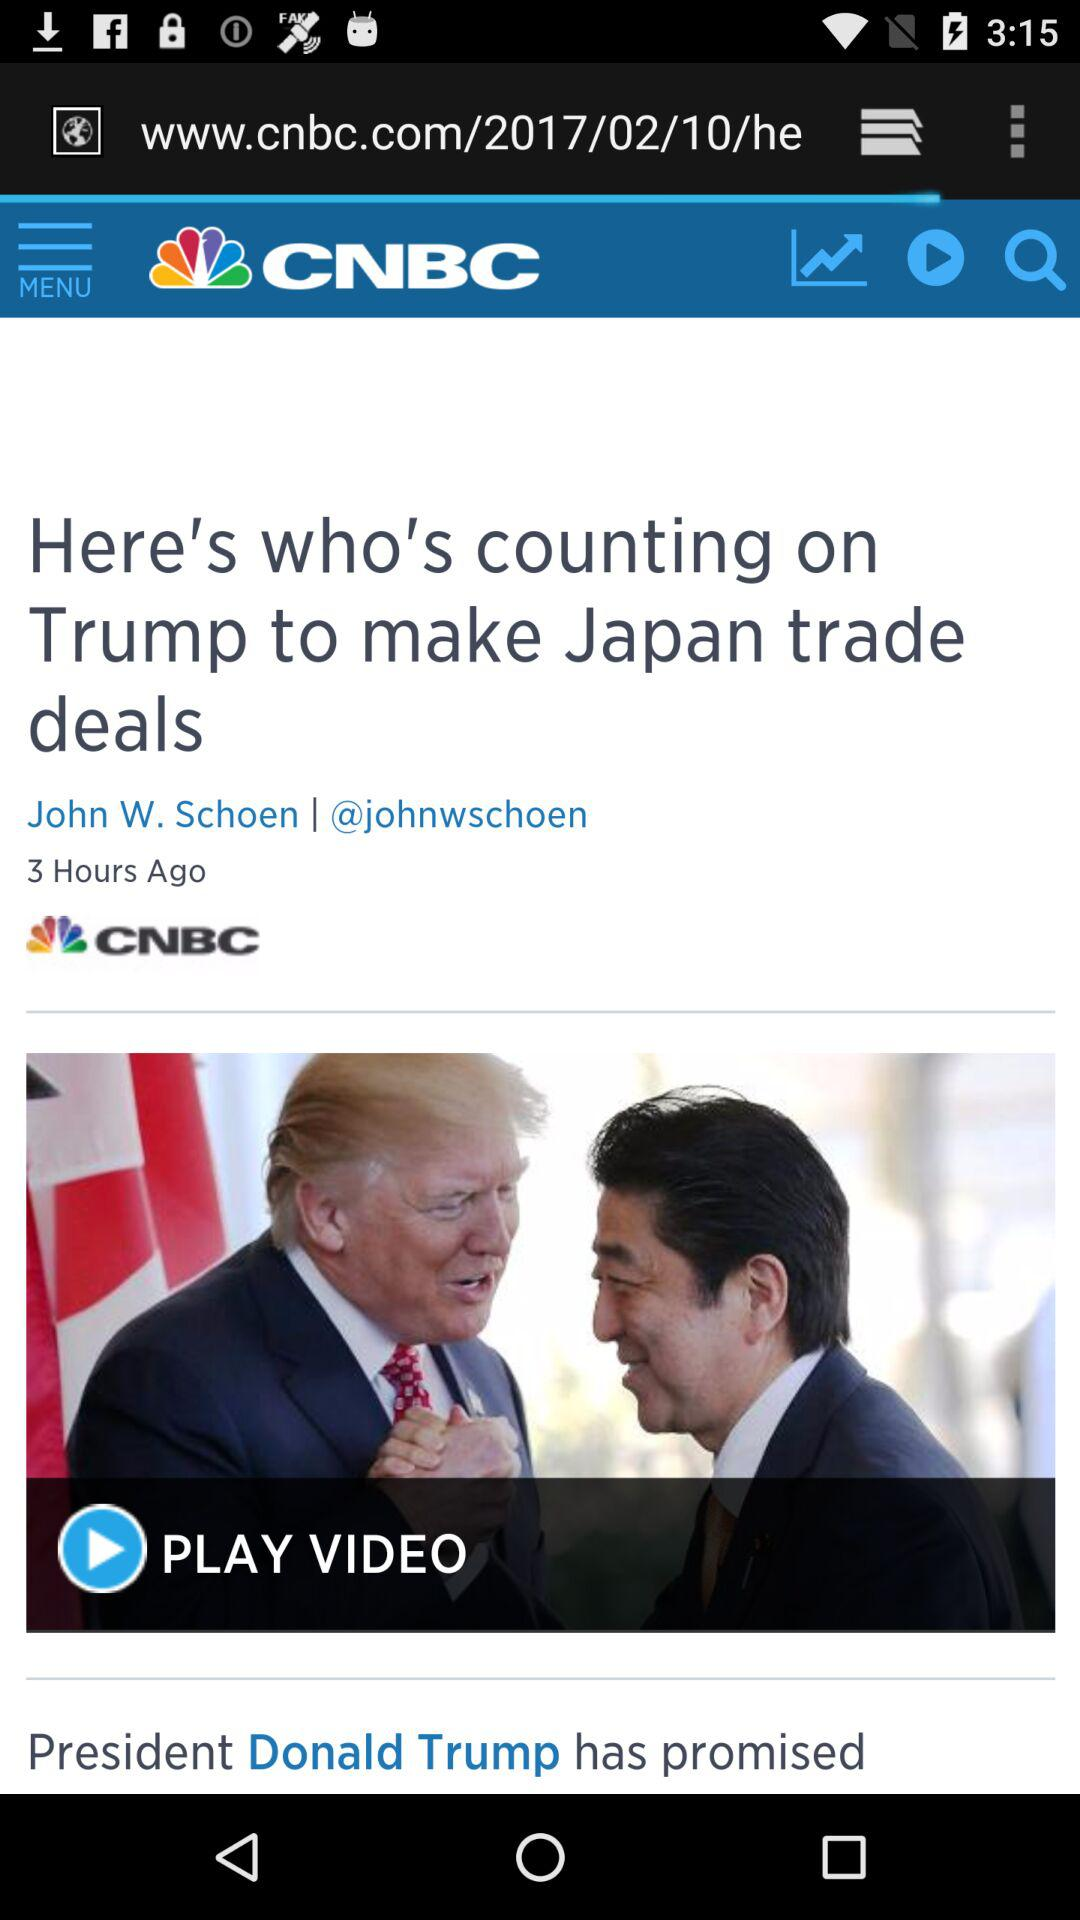How many hours ago was the news published? The news was published 3 hours ago. 